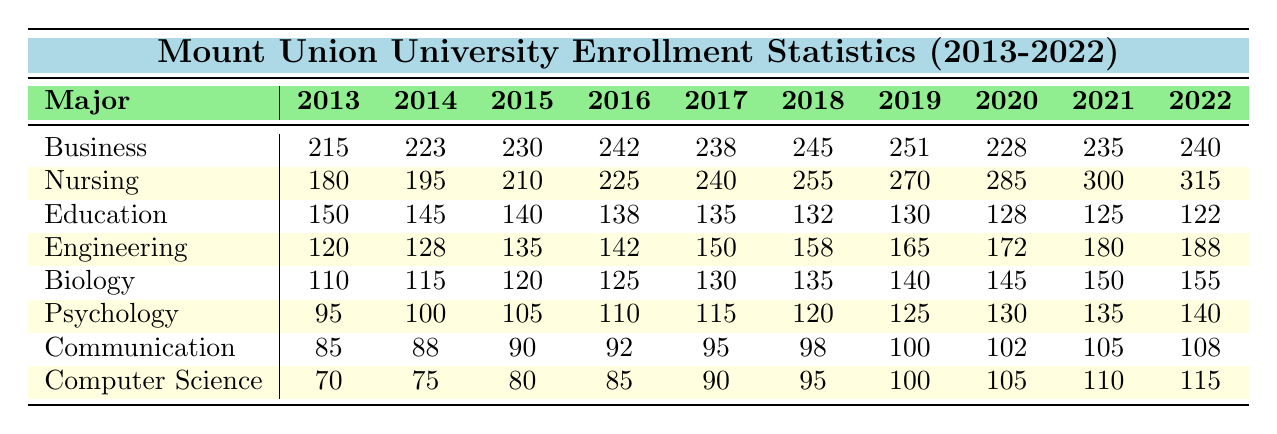What was the highest enrollment for Nursing during the past decade? The highest enrollment for Nursing is observed in 2022 with 315 students.
Answer: 315 Which major had the lowest enrollment in 2013? In 2013, the major with the lowest enrollment was Computer Science, with 70 students.
Answer: Computer Science What was the total enrollment for all majors in 2020? To find the total enrollment for 2020, sum the enrollments: 228 (Business) + 285 (Nursing) + 128 (Education) + 172 (Engineering) + 145 (Biology) + 130 (Psychology) + 102 (Communication) + 105 (Computer Science) = 1,165.
Answer: 1165 Did the enrollment for the Education major increase at any point between 2013 and 2022? No, the enrollment for Education consistently decreased from 2013 (150) to 2022 (122).
Answer: No What was the change in enrollment for the Psychology major from 2013 to 2022? The enrollment for Psychology increased from 95 in 2013 to 140 in 2022. The change is calculated as 140 - 95 = 45.
Answer: 45 Which major saw the largest increase in enrollment from 2013 to 2022? To determine the largest increase, we find the difference for each major: Business (25), Nursing (135), Education (-28), Engineering (68), Biology (45), Psychology (45), Communication (23), and Computer Science (45). The largest increase is for Nursing at 135.
Answer: Nursing In which year did the enrollment for Business drop below 230 for the first time? The enrollment for Business fell below 230 in 2020 when it had 228 students.
Answer: 2020 What was the average enrollment for Computer Science between 2013 and 2022? The total enrollment for Computer Science from 2013 to 2022 is 70 + 75 + 80 + 85 + 90 + 95 + 100 + 105 + 110 + 115 = 1,025. Dividing by 10 (the number of years) gives an average of 102.5.
Answer: 102.5 Is the enrollment trend for Nursing increasing or decreasing over the past decade? The enrollment for Nursing has continuously increased from 180 in 2013 to 315 in 2022, indicating an upward trend.
Answer: Increasing How many more students were enrolled in Engineering than in Biology in 2022? In 2022, Engineering had 188 students and Biology had 155. The difference is 188 - 155 = 33.
Answer: 33 